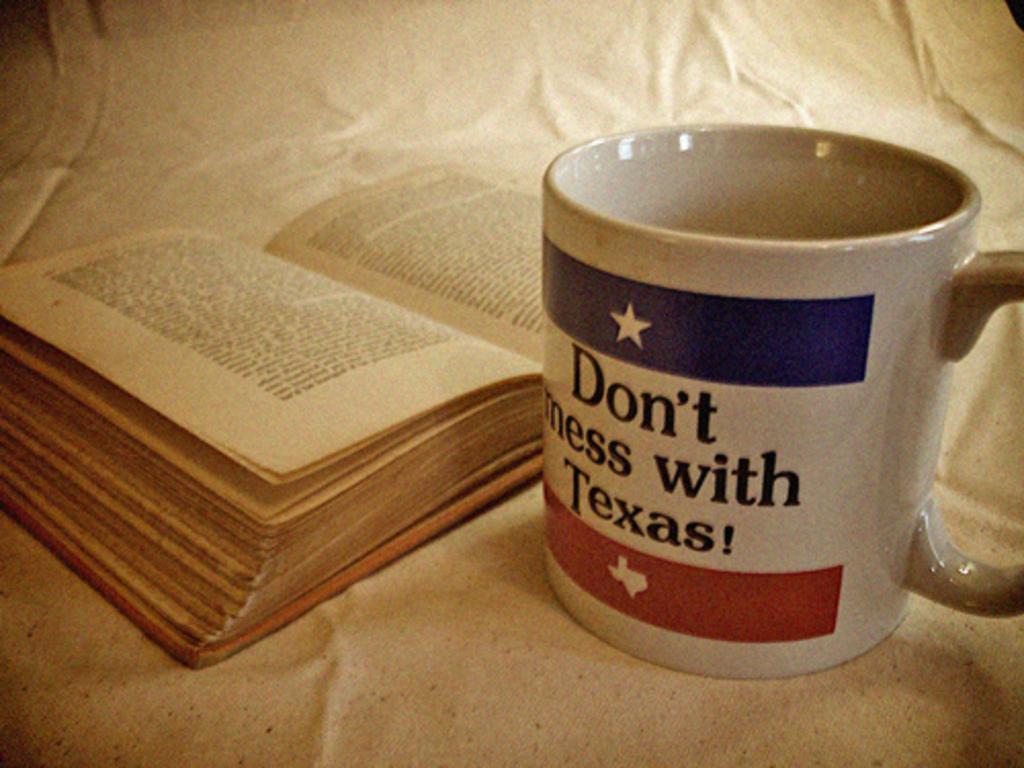What does the mug say?
Your answer should be very brief. Don't mess with texas!. What shouldn't you mess with?
Your response must be concise. Texas. 